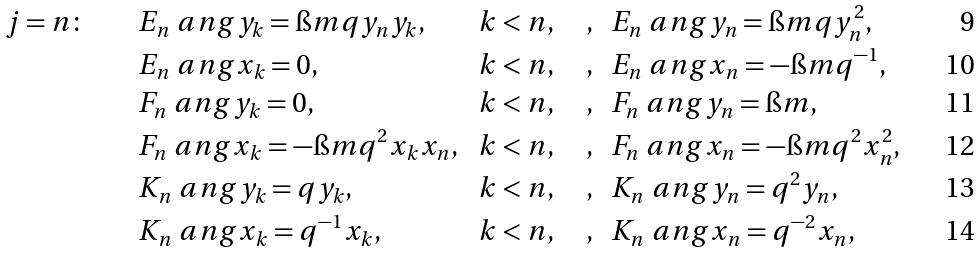<formula> <loc_0><loc_0><loc_500><loc_500>& j = n \colon \quad \ & & E _ { n } \ a n g y _ { k } = \i m q y _ { n } y _ { k } , & & \, k < n , \quad , & & E _ { n } \ a n g y _ { n } = \i m q y _ { n } ^ { 2 } , \\ & & & E _ { n } \ a n g x _ { k } = 0 , & & \, k < n , \quad , & & E _ { n } \ a n g x _ { n } = - \i m q ^ { - 1 } , \\ & & & F _ { n } \ a n g y _ { k } = 0 , & & \, k < n , \quad , & & F _ { n } \ a n g y _ { n } = \i m , \\ & & & F _ { n } \ a n g x _ { k } = - \i m q ^ { 2 } x _ { k } x _ { n } , & & \, k < n , \quad , & & F _ { n } \ a n g x _ { n } = - \i m q ^ { 2 } x ^ { 2 } _ { n } , \quad \\ & & & K _ { n } \ a n g y _ { k } = q y _ { k } , & & \, k < n , \quad , & & K _ { n } \ a n g y _ { n } = q ^ { 2 } y _ { n } , \\ & & & K _ { n } \ a n g x _ { k } = q ^ { - 1 } x _ { k } , & & \, k < n , \quad , & & K _ { n } \ a n g x _ { n } = q ^ { - 2 } x _ { n } ,</formula> 